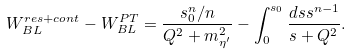<formula> <loc_0><loc_0><loc_500><loc_500>W _ { B L } ^ { r e s + c o n t } - W _ { B L } ^ { P T } = \frac { s _ { 0 } ^ { n } / n } { Q ^ { 2 } + m _ { { \eta } ^ { \prime } } ^ { 2 } } - \int _ { 0 } ^ { s _ { 0 } } \frac { d s s ^ { n - 1 } } { s + Q ^ { 2 } } .</formula> 